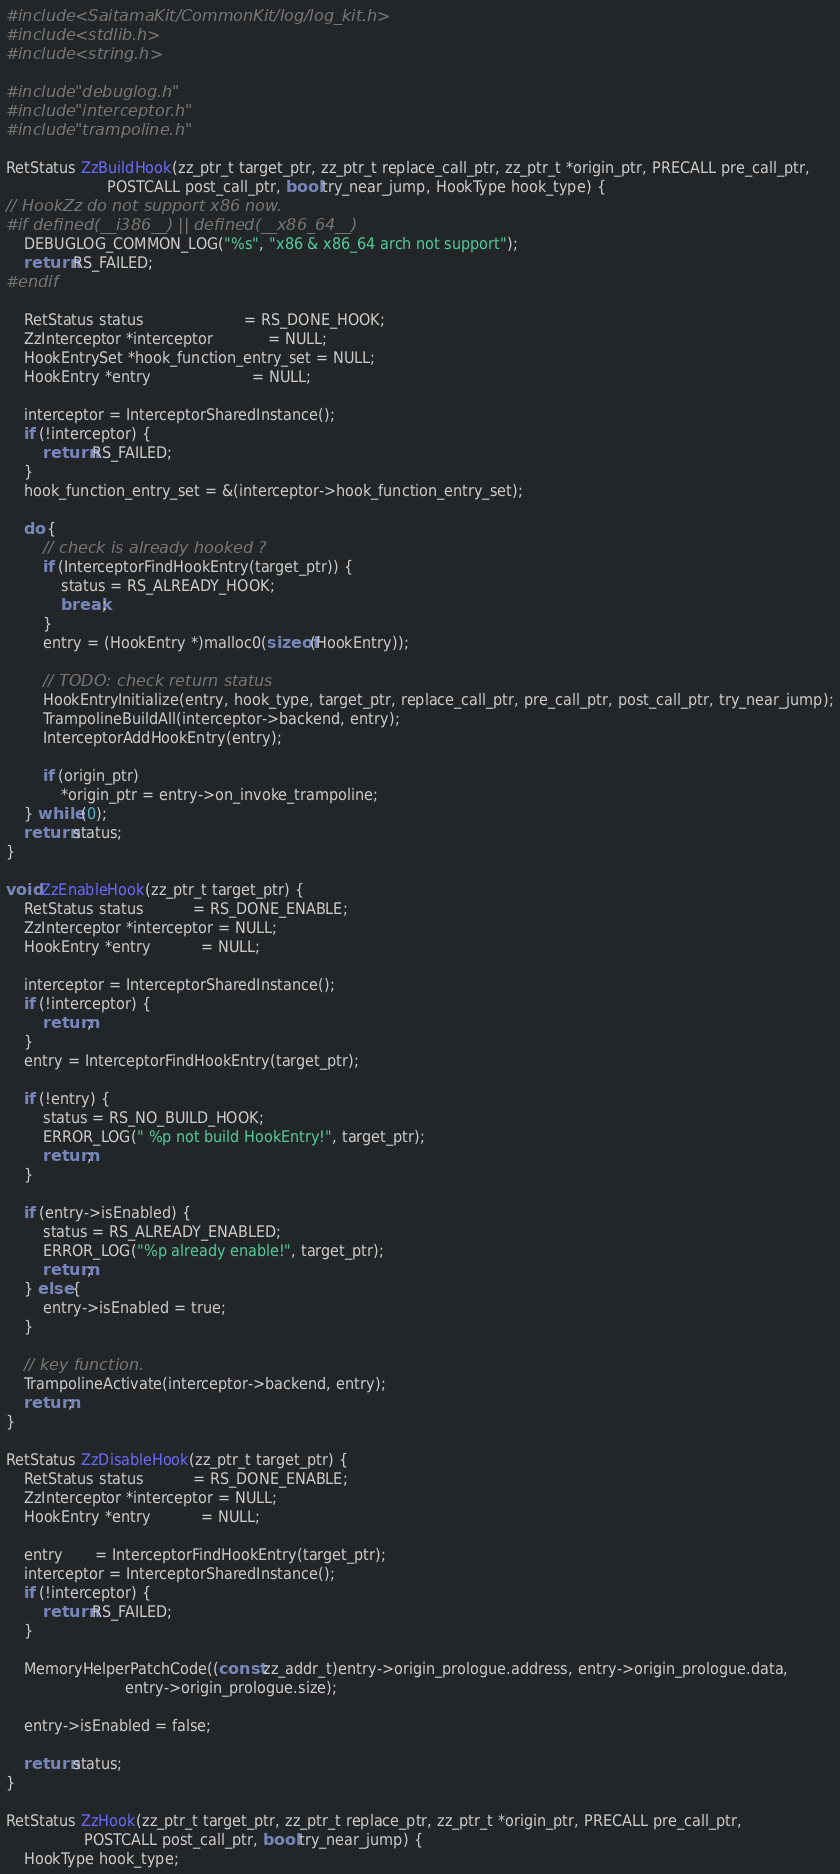Convert code to text. <code><loc_0><loc_0><loc_500><loc_500><_C_>#include <SaitamaKit/CommonKit/log/log_kit.h>
#include <stdlib.h>
#include <string.h>

#include "debuglog.h"
#include "interceptor.h"
#include "trampoline.h"

RetStatus ZzBuildHook(zz_ptr_t target_ptr, zz_ptr_t replace_call_ptr, zz_ptr_t *origin_ptr, PRECALL pre_call_ptr,
                      POSTCALL post_call_ptr, bool try_near_jump, HookType hook_type) {
// HookZz do not support x86 now.
#if defined(__i386__) || defined(__x86_64__)
    DEBUGLOG_COMMON_LOG("%s", "x86 & x86_64 arch not support");
    return RS_FAILED;
#endif

    RetStatus status                      = RS_DONE_HOOK;
    ZzInterceptor *interceptor            = NULL;
    HookEntrySet *hook_function_entry_set = NULL;
    HookEntry *entry                      = NULL;

    interceptor = InterceptorSharedInstance();
    if (!interceptor) {
        return RS_FAILED;
    }
    hook_function_entry_set = &(interceptor->hook_function_entry_set);

    do {
        // check is already hooked ?
        if (InterceptorFindHookEntry(target_ptr)) {
            status = RS_ALREADY_HOOK;
            break;
        }
        entry = (HookEntry *)malloc0(sizeof(HookEntry));

        // TODO: check return status
        HookEntryInitialize(entry, hook_type, target_ptr, replace_call_ptr, pre_call_ptr, post_call_ptr, try_near_jump);
        TrampolineBuildAll(interceptor->backend, entry);
        InterceptorAddHookEntry(entry);

        if (origin_ptr)
            *origin_ptr = entry->on_invoke_trampoline;
    } while (0);
    return status;
}

void ZzEnableHook(zz_ptr_t target_ptr) {
    RetStatus status           = RS_DONE_ENABLE;
    ZzInterceptor *interceptor = NULL;
    HookEntry *entry           = NULL;

    interceptor = InterceptorSharedInstance();
    if (!interceptor) {
        return;
    }
    entry = InterceptorFindHookEntry(target_ptr);

    if (!entry) {
        status = RS_NO_BUILD_HOOK;
        ERROR_LOG(" %p not build HookEntry!", target_ptr);
        return;
    }

    if (entry->isEnabled) {
        status = RS_ALREADY_ENABLED;
        ERROR_LOG("%p already enable!", target_ptr);
        return;
    } else {
        entry->isEnabled = true;
    }

    // key function.
    TrampolineActivate(interceptor->backend, entry);
    return;
}

RetStatus ZzDisableHook(zz_ptr_t target_ptr) {
    RetStatus status           = RS_DONE_ENABLE;
    ZzInterceptor *interceptor = NULL;
    HookEntry *entry           = NULL;

    entry       = InterceptorFindHookEntry(target_ptr);
    interceptor = InterceptorSharedInstance();
    if (!interceptor) {
        return RS_FAILED;
    }

    MemoryHelperPatchCode((const zz_addr_t)entry->origin_prologue.address, entry->origin_prologue.data,
                          entry->origin_prologue.size);

    entry->isEnabled = false;

    return status;
}

RetStatus ZzHook(zz_ptr_t target_ptr, zz_ptr_t replace_ptr, zz_ptr_t *origin_ptr, PRECALL pre_call_ptr,
                 POSTCALL post_call_ptr, bool try_near_jump) {
    HookType hook_type;</code> 